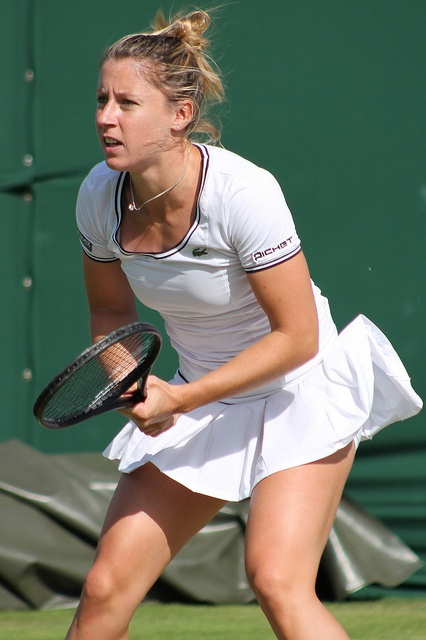Describe the objects in this image and their specific colors. I can see people in teal, white, tan, and darkgray tones and tennis racket in teal, black, gray, and darkgreen tones in this image. 